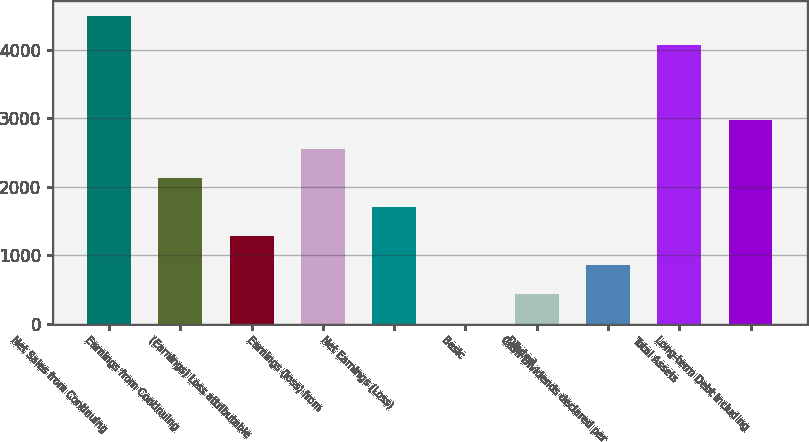Convert chart. <chart><loc_0><loc_0><loc_500><loc_500><bar_chart><fcel>Net Sales from Continuing<fcel>Earnings from Continuing<fcel>(Earnings) Loss attributable<fcel>Earnings (loss) from<fcel>Net Earnings (Loss)<fcel>Basic<fcel>Diluted<fcel>Cash Dividends declared per<fcel>Total Assets<fcel>Long-term Debt including<nl><fcel>4496.97<fcel>2125.18<fcel>1275.24<fcel>2550.15<fcel>1700.21<fcel>0.33<fcel>425.3<fcel>850.27<fcel>4072<fcel>2975.12<nl></chart> 